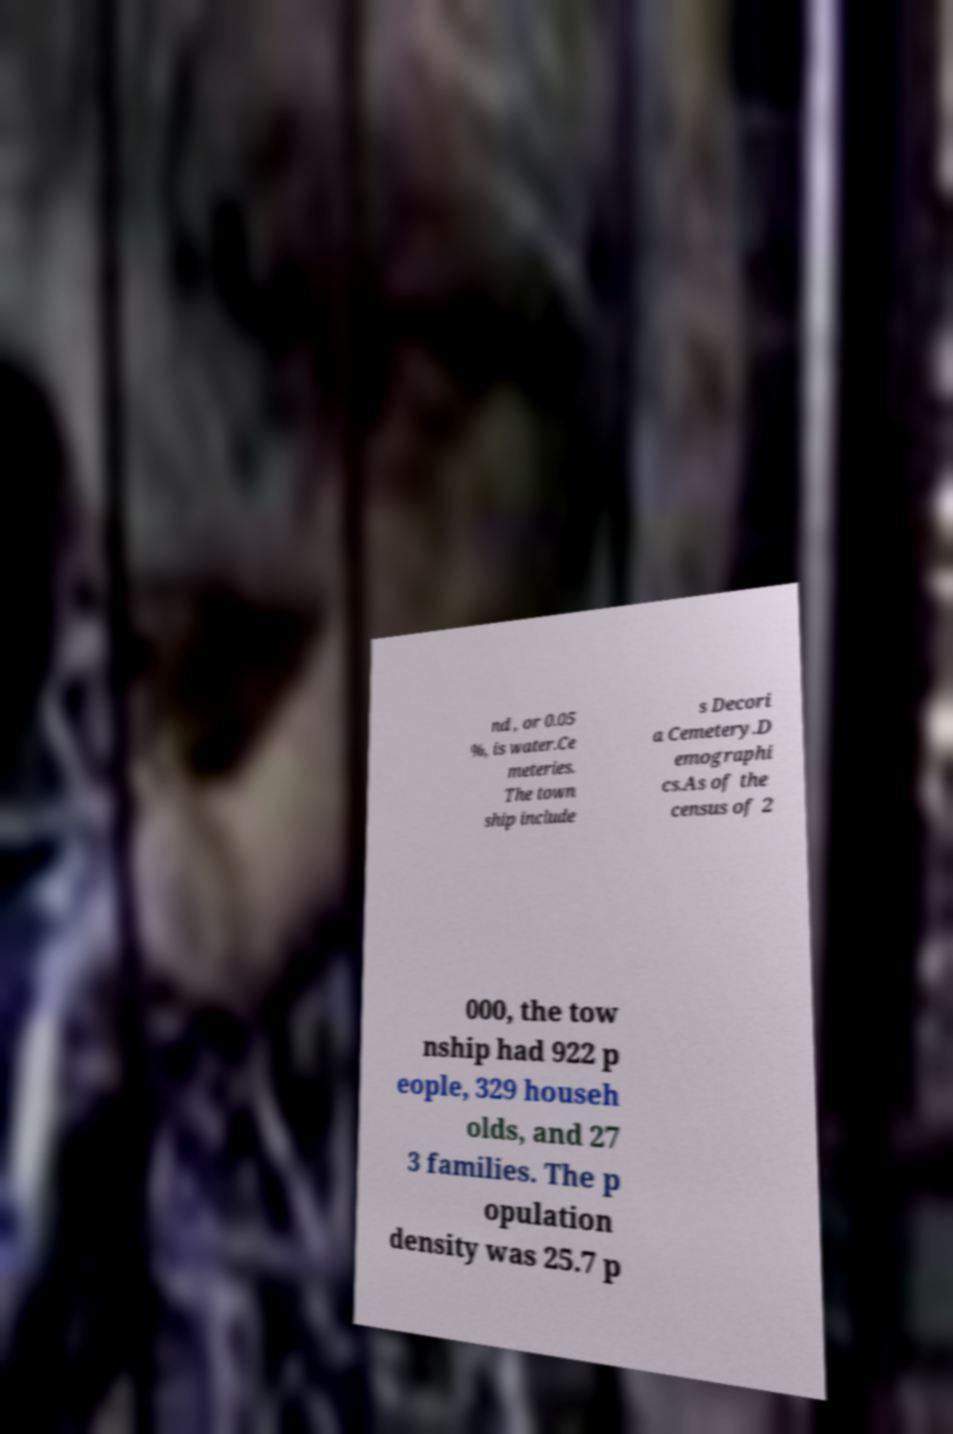For documentation purposes, I need the text within this image transcribed. Could you provide that? nd , or 0.05 %, is water.Ce meteries. The town ship include s Decori a Cemetery.D emographi cs.As of the census of 2 000, the tow nship had 922 p eople, 329 househ olds, and 27 3 families. The p opulation density was 25.7 p 